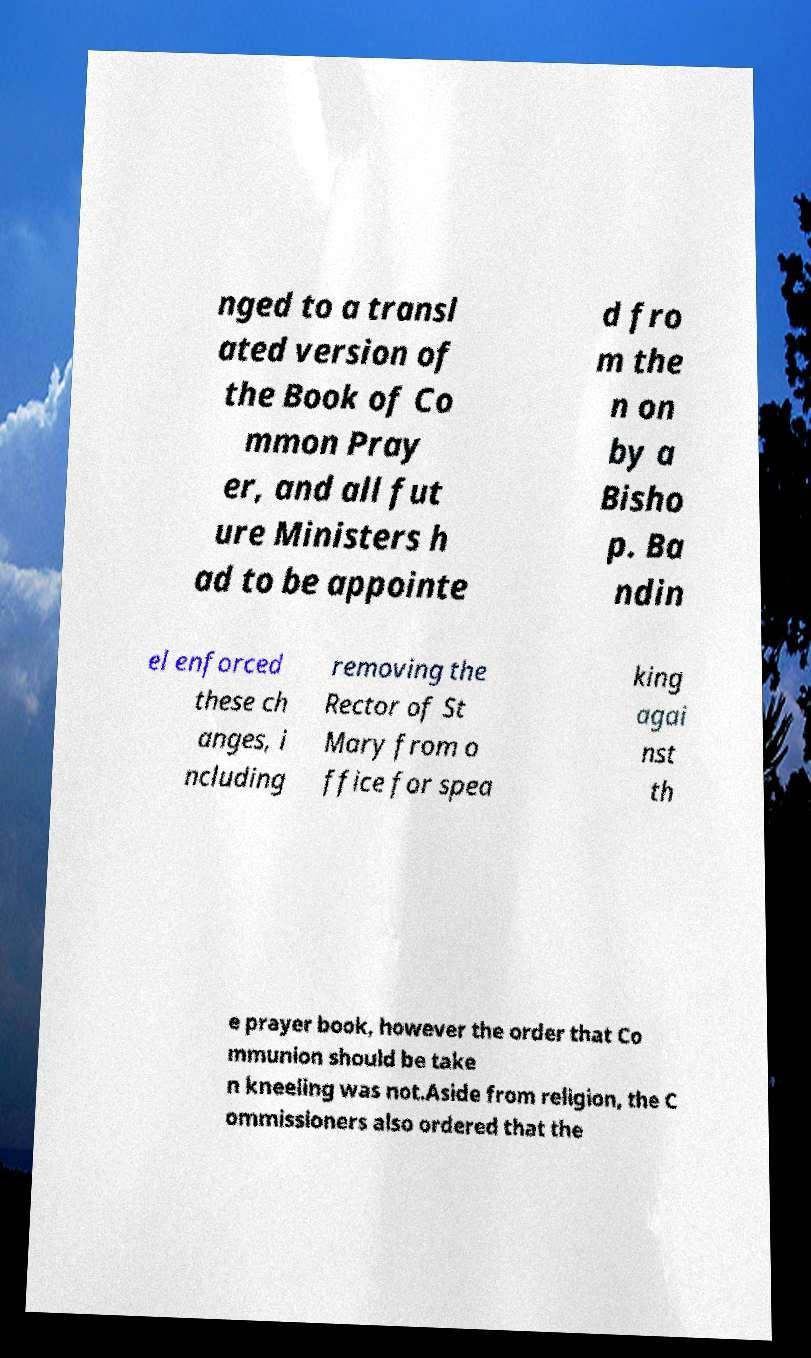Please identify and transcribe the text found in this image. nged to a transl ated version of the Book of Co mmon Pray er, and all fut ure Ministers h ad to be appointe d fro m the n on by a Bisho p. Ba ndin el enforced these ch anges, i ncluding removing the Rector of St Mary from o ffice for spea king agai nst th e prayer book, however the order that Co mmunion should be take n kneeling was not.Aside from religion, the C ommissioners also ordered that the 